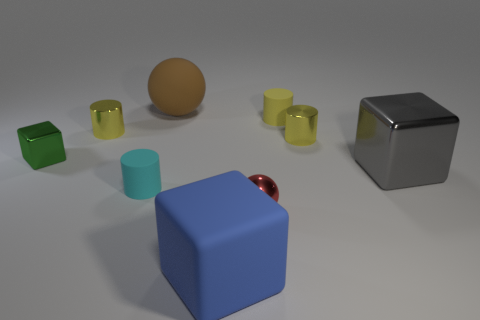Are there more small metal cylinders in front of the green block than small yellow cylinders on the right side of the gray metallic block?
Give a very brief answer. No. What is the material of the big cube on the right side of the large blue thing in front of the matte cylinder that is on the right side of the large brown object?
Offer a very short reply. Metal. Does the tiny matte object that is in front of the green block have the same shape as the small yellow metal object that is to the right of the big ball?
Provide a succinct answer. Yes. Are there any red metallic objects that have the same size as the gray cube?
Keep it short and to the point. No. How many red things are either small rubber cylinders or matte things?
Your answer should be very brief. 0. What number of other big rubber blocks have the same color as the rubber cube?
Your answer should be very brief. 0. Are there any other things that have the same shape as the yellow rubber thing?
Offer a very short reply. Yes. What number of cylinders are either green things or tiny metallic things?
Provide a short and direct response. 2. What color is the tiny matte thing on the right side of the big blue rubber object?
Offer a very short reply. Yellow. There is a blue rubber object that is the same size as the gray cube; what is its shape?
Your response must be concise. Cube. 